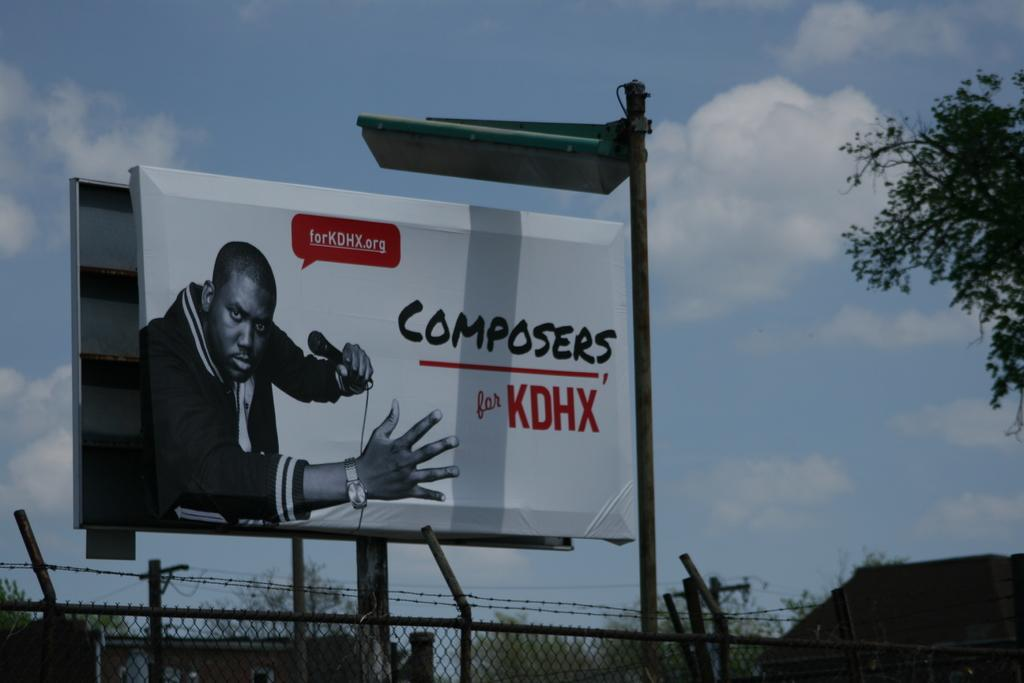Provide a one-sentence caption for the provided image. A billboard advertising Composers for KDHX on the side of a street. 